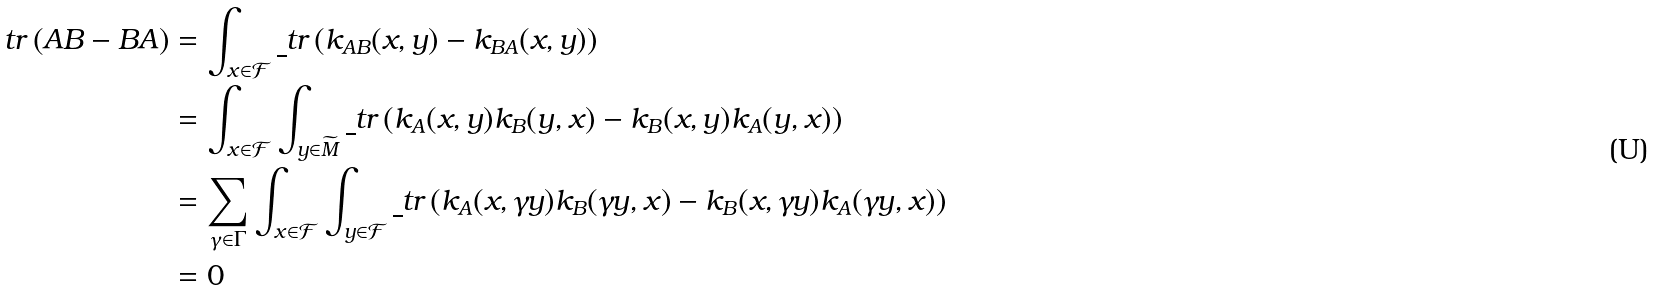Convert formula to latex. <formula><loc_0><loc_0><loc_500><loc_500>\ t r \left ( A B - B A \right ) & = \int _ { x \in \mathcal { F } } \underline { \ } t r \left ( k _ { A B } ( x , y ) - k _ { B A } ( x , y ) \right ) \\ & = \int _ { x \in \mathcal { F } } \int _ { y \in \widetilde { M } } \underline { \ } t r \left ( k _ { A } ( x , y ) k _ { B } ( y , x ) - k _ { B } ( x , y ) k _ { A } ( y , x ) \right ) \\ & = \sum _ { \gamma \in \Gamma } \int _ { x \in \mathcal { F } } \int _ { y \in \mathcal { F } } \underline { \ } t r \left ( k _ { A } ( x , \gamma y ) k _ { B } ( \gamma y , x ) - k _ { B } ( x , \gamma y ) k _ { A } ( \gamma y , x ) \right ) \\ & = 0</formula> 